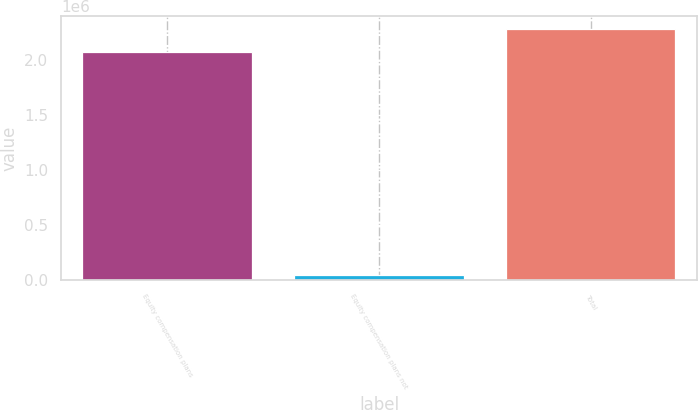<chart> <loc_0><loc_0><loc_500><loc_500><bar_chart><fcel>Equity compensation plans<fcel>Equity compensation plans not<fcel>Total<nl><fcel>2.07372e+06<fcel>47195<fcel>2.28109e+06<nl></chart> 